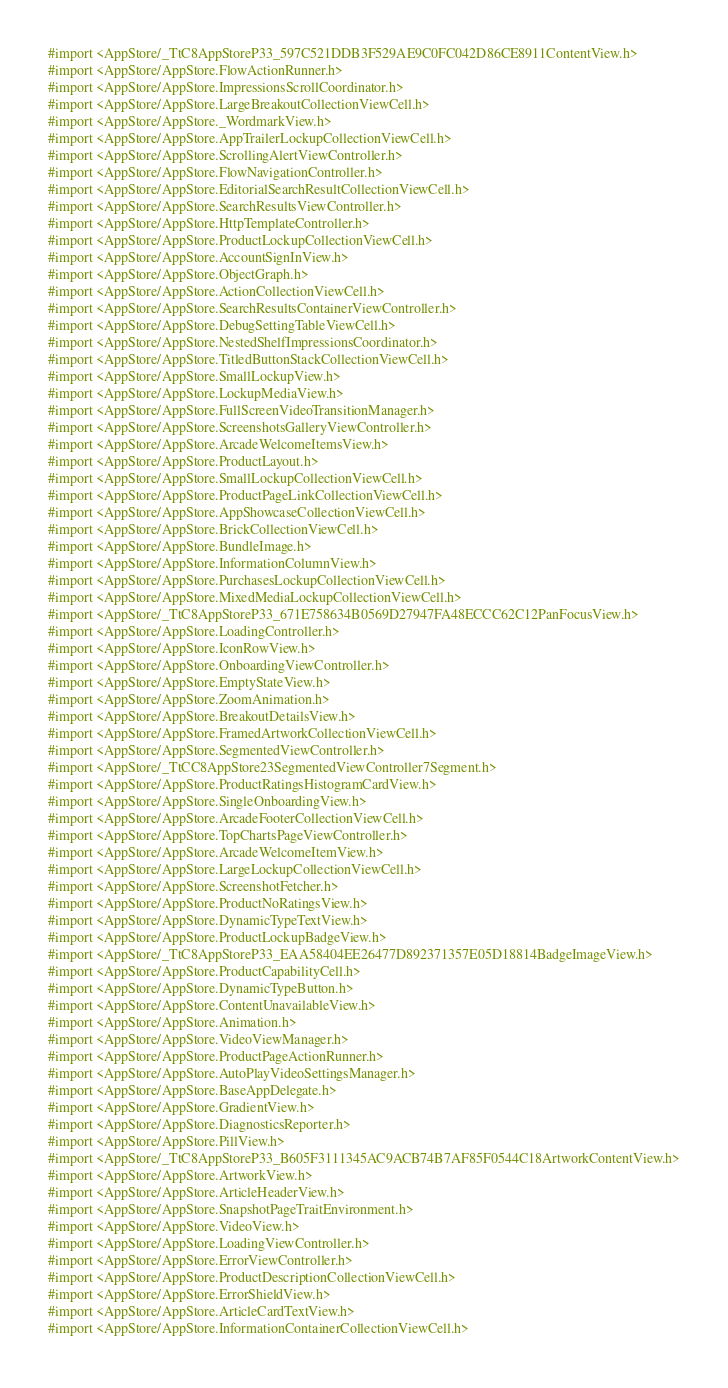<code> <loc_0><loc_0><loc_500><loc_500><_C_>#import <AppStore/_TtC8AppStoreP33_597C521DDB3F529AE9C0FC042D86CE8911ContentView.h>
#import <AppStore/AppStore.FlowActionRunner.h>
#import <AppStore/AppStore.ImpressionsScrollCoordinator.h>
#import <AppStore/AppStore.LargeBreakoutCollectionViewCell.h>
#import <AppStore/AppStore._WordmarkView.h>
#import <AppStore/AppStore.AppTrailerLockupCollectionViewCell.h>
#import <AppStore/AppStore.ScrollingAlertViewController.h>
#import <AppStore/AppStore.FlowNavigationController.h>
#import <AppStore/AppStore.EditorialSearchResultCollectionViewCell.h>
#import <AppStore/AppStore.SearchResultsViewController.h>
#import <AppStore/AppStore.HttpTemplateController.h>
#import <AppStore/AppStore.ProductLockupCollectionViewCell.h>
#import <AppStore/AppStore.AccountSignInView.h>
#import <AppStore/AppStore.ObjectGraph.h>
#import <AppStore/AppStore.ActionCollectionViewCell.h>
#import <AppStore/AppStore.SearchResultsContainerViewController.h>
#import <AppStore/AppStore.DebugSettingTableViewCell.h>
#import <AppStore/AppStore.NestedShelfImpressionsCoordinator.h>
#import <AppStore/AppStore.TitledButtonStackCollectionViewCell.h>
#import <AppStore/AppStore.SmallLockupView.h>
#import <AppStore/AppStore.LockupMediaView.h>
#import <AppStore/AppStore.FullScreenVideoTransitionManager.h>
#import <AppStore/AppStore.ScreenshotsGalleryViewController.h>
#import <AppStore/AppStore.ArcadeWelcomeItemsView.h>
#import <AppStore/AppStore.ProductLayout.h>
#import <AppStore/AppStore.SmallLockupCollectionViewCell.h>
#import <AppStore/AppStore.ProductPageLinkCollectionViewCell.h>
#import <AppStore/AppStore.AppShowcaseCollectionViewCell.h>
#import <AppStore/AppStore.BrickCollectionViewCell.h>
#import <AppStore/AppStore.BundleImage.h>
#import <AppStore/AppStore.InformationColumnView.h>
#import <AppStore/AppStore.PurchasesLockupCollectionViewCell.h>
#import <AppStore/AppStore.MixedMediaLockupCollectionViewCell.h>
#import <AppStore/_TtC8AppStoreP33_671E758634B0569D27947FA48ECCC62C12PanFocusView.h>
#import <AppStore/AppStore.LoadingController.h>
#import <AppStore/AppStore.IconRowView.h>
#import <AppStore/AppStore.OnboardingViewController.h>
#import <AppStore/AppStore.EmptyStateView.h>
#import <AppStore/AppStore.ZoomAnimation.h>
#import <AppStore/AppStore.BreakoutDetailsView.h>
#import <AppStore/AppStore.FramedArtworkCollectionViewCell.h>
#import <AppStore/AppStore.SegmentedViewController.h>
#import <AppStore/_TtCC8AppStore23SegmentedViewController7Segment.h>
#import <AppStore/AppStore.ProductRatingsHistogramCardView.h>
#import <AppStore/AppStore.SingleOnboardingView.h>
#import <AppStore/AppStore.ArcadeFooterCollectionViewCell.h>
#import <AppStore/AppStore.TopChartsPageViewController.h>
#import <AppStore/AppStore.ArcadeWelcomeItemView.h>
#import <AppStore/AppStore.LargeLockupCollectionViewCell.h>
#import <AppStore/AppStore.ScreenshotFetcher.h>
#import <AppStore/AppStore.ProductNoRatingsView.h>
#import <AppStore/AppStore.DynamicTypeTextView.h>
#import <AppStore/AppStore.ProductLockupBadgeView.h>
#import <AppStore/_TtC8AppStoreP33_EAA58404EE26477D892371357E05D18814BadgeImageView.h>
#import <AppStore/AppStore.ProductCapabilityCell.h>
#import <AppStore/AppStore.DynamicTypeButton.h>
#import <AppStore/AppStore.ContentUnavailableView.h>
#import <AppStore/AppStore.Animation.h>
#import <AppStore/AppStore.VideoViewManager.h>
#import <AppStore/AppStore.ProductPageActionRunner.h>
#import <AppStore/AppStore.AutoPlayVideoSettingsManager.h>
#import <AppStore/AppStore.BaseAppDelegate.h>
#import <AppStore/AppStore.GradientView.h>
#import <AppStore/AppStore.DiagnosticsReporter.h>
#import <AppStore/AppStore.PillView.h>
#import <AppStore/_TtC8AppStoreP33_B605F3111345AC9ACB74B7AF85F0544C18ArtworkContentView.h>
#import <AppStore/AppStore.ArtworkView.h>
#import <AppStore/AppStore.ArticleHeaderView.h>
#import <AppStore/AppStore.SnapshotPageTraitEnvironment.h>
#import <AppStore/AppStore.VideoView.h>
#import <AppStore/AppStore.LoadingViewController.h>
#import <AppStore/AppStore.ErrorViewController.h>
#import <AppStore/AppStore.ProductDescriptionCollectionViewCell.h>
#import <AppStore/AppStore.ErrorShieldView.h>
#import <AppStore/AppStore.ArticleCardTextView.h>
#import <AppStore/AppStore.InformationContainerCollectionViewCell.h></code> 